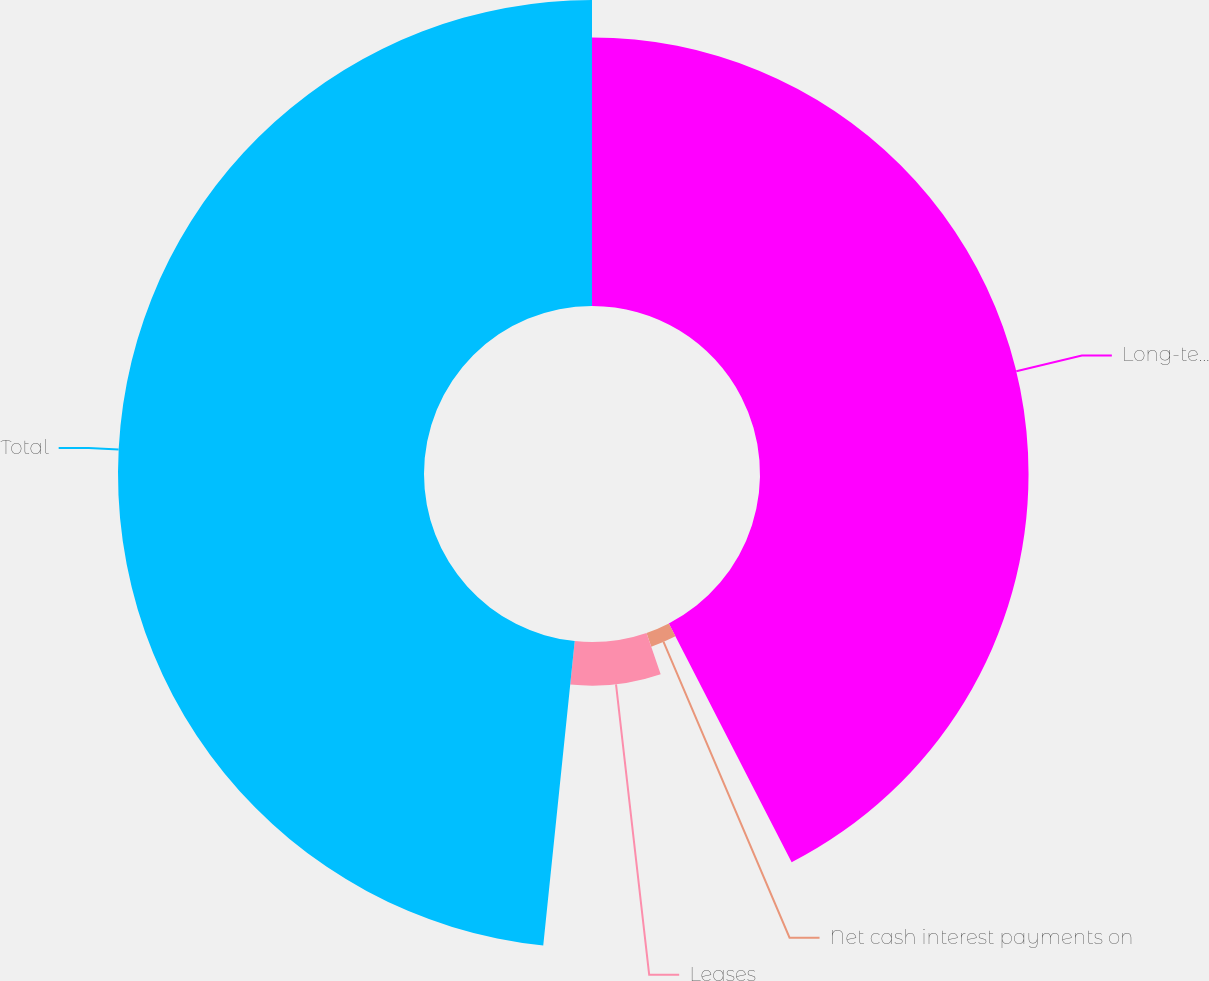<chart> <loc_0><loc_0><loc_500><loc_500><pie_chart><fcel>Long-term debt including<fcel>Net cash interest payments on<fcel>Leases<fcel>Total<nl><fcel>42.44%<fcel>2.3%<fcel>6.9%<fcel>48.36%<nl></chart> 